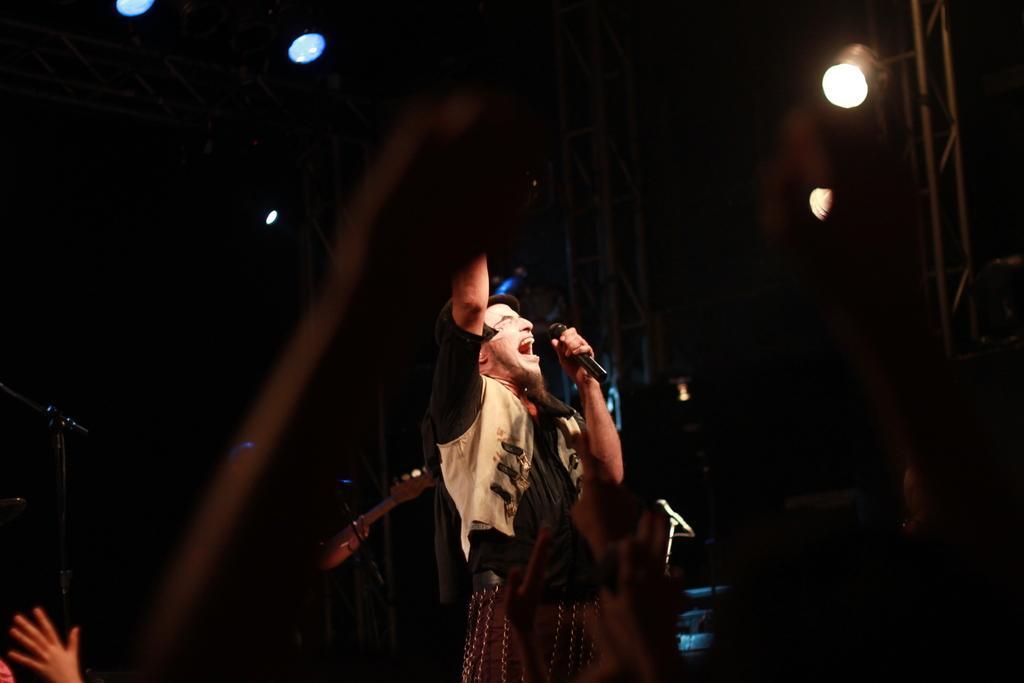Describe this image in one or two sentences. In this image we can see a person, microphone and other objects. In the background of the image there are lights and other objects. On the left side of the image there is a stand and a person's hand. At the bottom of the image there are some persons hands. 